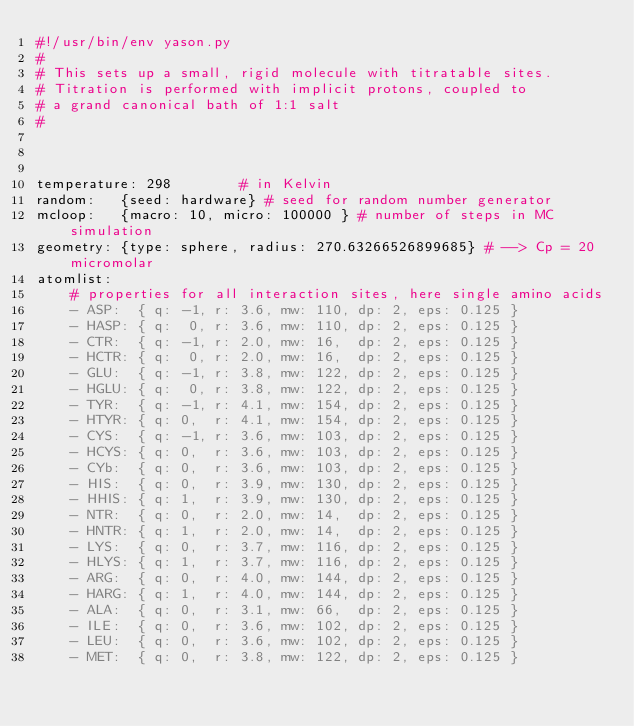<code> <loc_0><loc_0><loc_500><loc_500><_YAML_>#!/usr/bin/env yason.py
#
# This sets up a small, rigid molecule with titratable sites.
# Titration is performed with implicit protons, coupled to
# a grand canonical bath of 1:1 salt
#



temperature: 298        # in Kelvin
random:   {seed: hardware} # seed for random number generator
mcloop:   {macro: 10, micro: 100000 } # number of steps in MC simulation
geometry: {type: sphere, radius: 270.63266526899685} # --> Cp = 20 micromolar
atomlist:
    # properties for all interaction sites, here single amino acids
    - ASP:  { q: -1, r: 3.6, mw: 110, dp: 2, eps: 0.125 }
    - HASP: { q:  0, r: 3.6, mw: 110, dp: 2, eps: 0.125 }
    - CTR:  { q: -1, r: 2.0, mw: 16,  dp: 2, eps: 0.125 }
    - HCTR: { q:  0, r: 2.0, mw: 16,  dp: 2, eps: 0.125 }
    - GLU:  { q: -1, r: 3.8, mw: 122, dp: 2, eps: 0.125 }
    - HGLU: { q:  0, r: 3.8, mw: 122, dp: 2, eps: 0.125 }
    - TYR:  { q: -1, r: 4.1, mw: 154, dp: 2, eps: 0.125 }
    - HTYR: { q: 0,  r: 4.1, mw: 154, dp: 2, eps: 0.125 }
    - CYS:  { q: -1, r: 3.6, mw: 103, dp: 2, eps: 0.125 }
    - HCYS: { q: 0,  r: 3.6, mw: 103, dp: 2, eps: 0.125 }
    - CYb:  { q: 0,  r: 3.6, mw: 103, dp: 2, eps: 0.125 }
    - HIS:  { q: 0,  r: 3.9, mw: 130, dp: 2, eps: 0.125 }
    - HHIS: { q: 1,  r: 3.9, mw: 130, dp: 2, eps: 0.125 }
    - NTR:  { q: 0,  r: 2.0, mw: 14,  dp: 2, eps: 0.125 }
    - HNTR: { q: 1,  r: 2.0, mw: 14,  dp: 2, eps: 0.125 }
    - LYS:  { q: 0,  r: 3.7, mw: 116, dp: 2, eps: 0.125 }
    - HLYS: { q: 1,  r: 3.7, mw: 116, dp: 2, eps: 0.125 }
    - ARG:  { q: 0,  r: 4.0, mw: 144, dp: 2, eps: 0.125 }
    - HARG: { q: 1,  r: 4.0, mw: 144, dp: 2, eps: 0.125 }
    - ALA:  { q: 0,  r: 3.1, mw: 66,  dp: 2, eps: 0.125 }
    - ILE:  { q: 0,  r: 3.6, mw: 102, dp: 2, eps: 0.125 }
    - LEU:  { q: 0,  r: 3.6, mw: 102, dp: 2, eps: 0.125 }
    - MET:  { q: 0,  r: 3.8, mw: 122, dp: 2, eps: 0.125 }</code> 